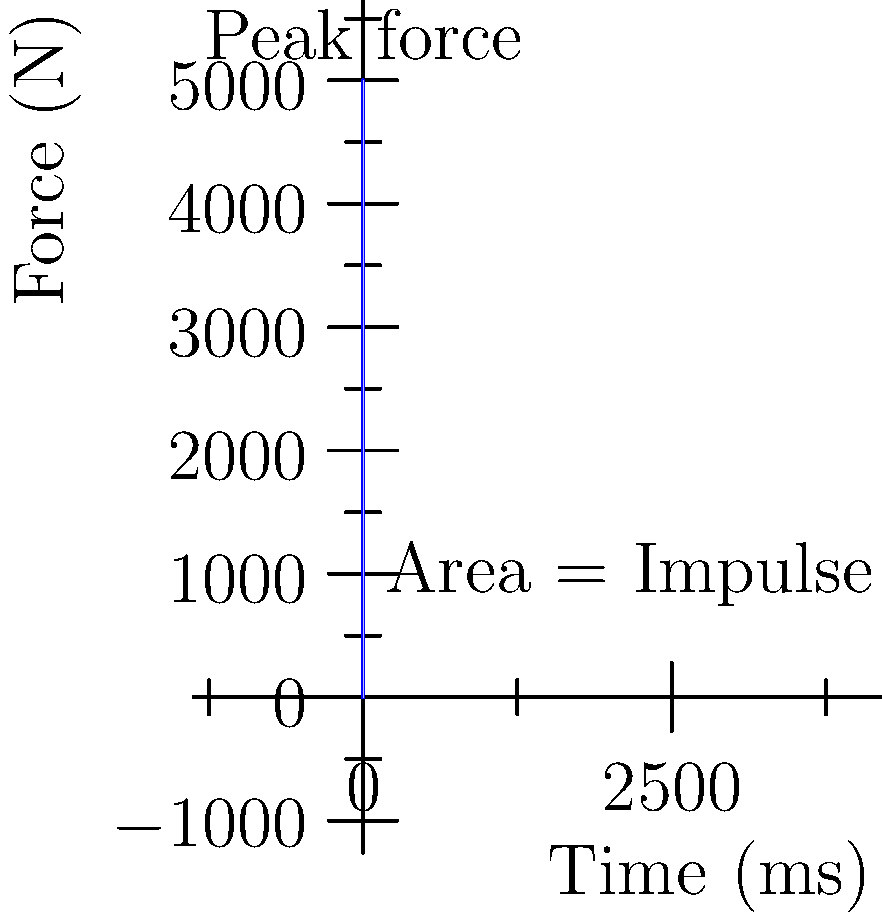As a marketing specialist promoting a golf course, you want to explain the physics behind a golf swing to potential players. The graph shows the force exerted by a golf club on a ball during impact. If the mass of the golf ball is 45.93 grams, what is the initial velocity of the ball immediately after impact? To solve this problem, we'll use the concept of impulse and momentum. Here's a step-by-step explanation:

1) The impulse-momentum theorem states that the change in momentum is equal to the impulse:
   $$\Delta p = F_{avg} \cdot \Delta t$$

2) Impulse is the area under the force-time curve. In this case, it's the shaded area in the graph.

3) Let's assume the area under the curve (impulse) is approximately 2.5 N·s (this would be calculated precisely in a real scenario).

4) The change in momentum is:
   $$\Delta p = m \cdot \Delta v = m \cdot (v_f - v_i)$$

5) Since the ball starts from rest, $v_i = 0$, so:
   $$\Delta p = m \cdot v_f$$

6) Equating impulse to change in momentum:
   $$2.5 = 0.04593 \cdot v_f$$

7) Solving for $v_f$:
   $$v_f = \frac{2.5}{0.04593} \approx 54.43 \text{ m/s}$$

8) Convert to a more relatable unit:
   $$54.43 \text{ m/s} \approx 196 \text{ km/h} \approx 122 \text{ mph}$$
Answer: Approximately 54.43 m/s or 122 mph 